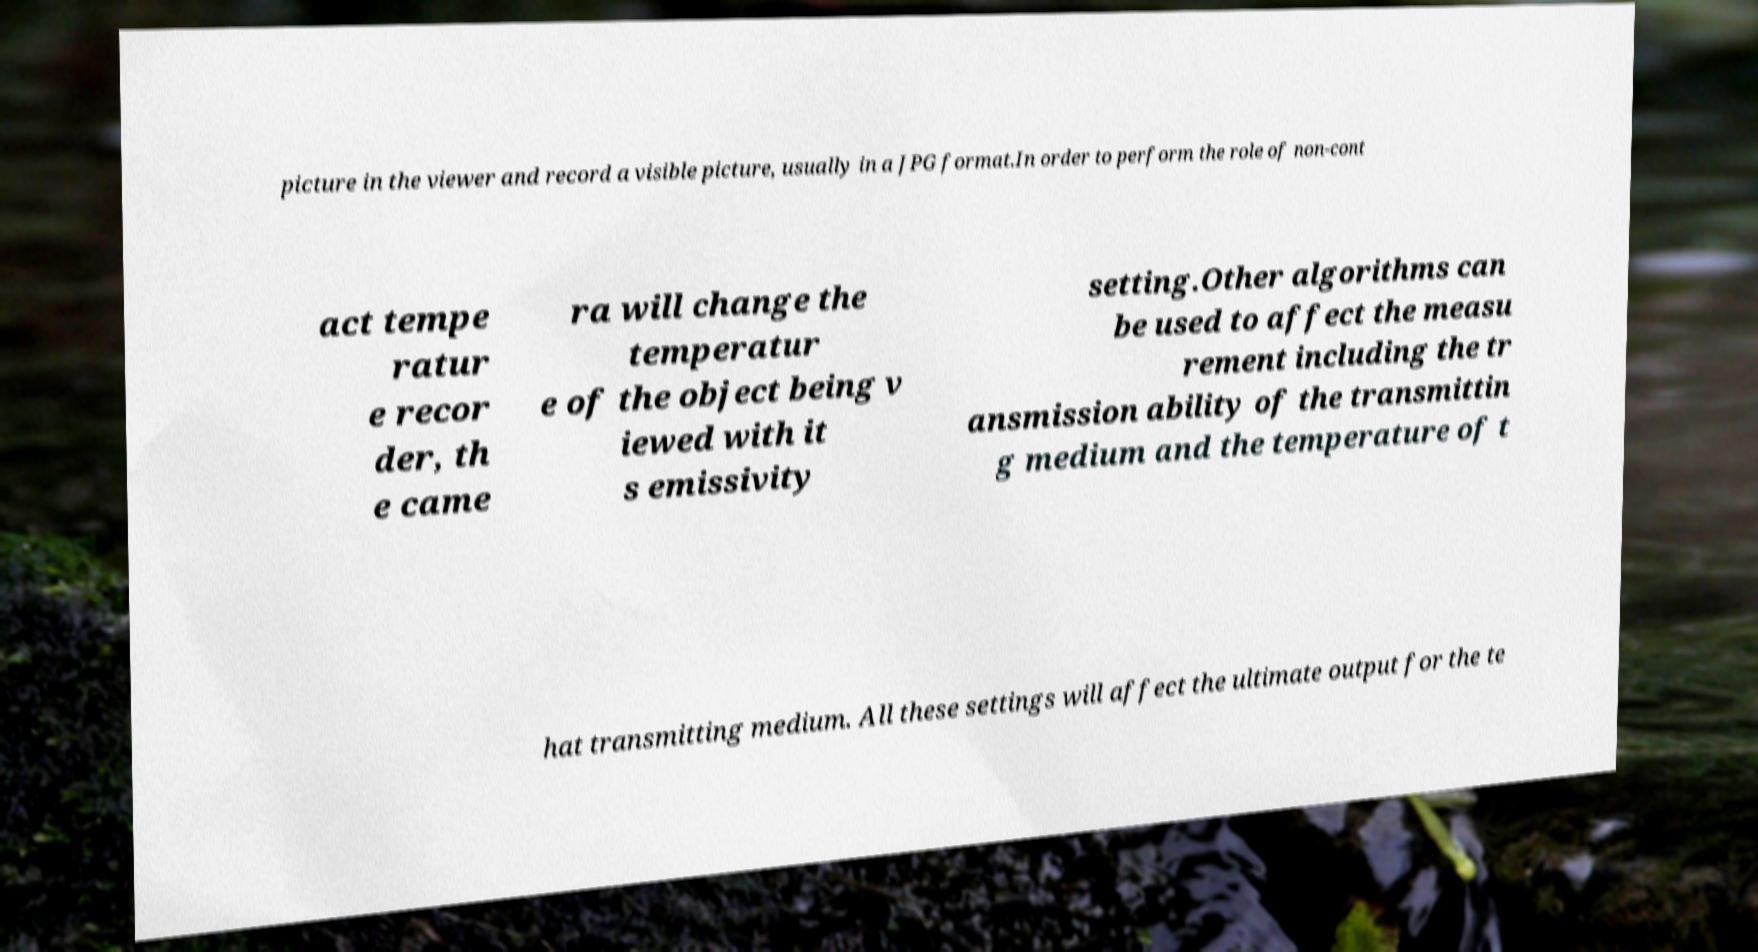For documentation purposes, I need the text within this image transcribed. Could you provide that? picture in the viewer and record a visible picture, usually in a JPG format.In order to perform the role of non-cont act tempe ratur e recor der, th e came ra will change the temperatur e of the object being v iewed with it s emissivity setting.Other algorithms can be used to affect the measu rement including the tr ansmission ability of the transmittin g medium and the temperature of t hat transmitting medium. All these settings will affect the ultimate output for the te 